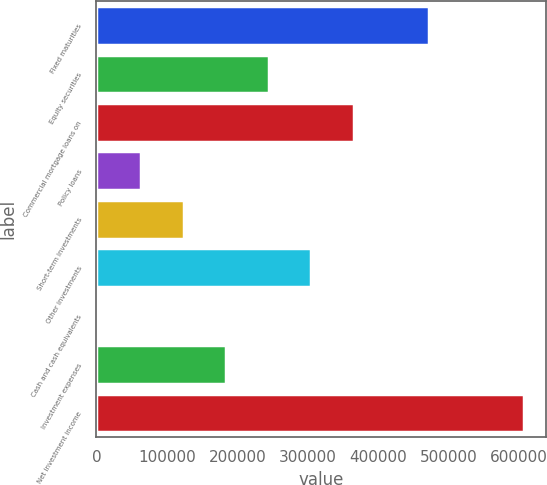Convert chart to OTSL. <chart><loc_0><loc_0><loc_500><loc_500><bar_chart><fcel>Fixed maturities<fcel>Equity securities<fcel>Commercial mortgage loans on<fcel>Policy loans<fcel>Short-term investments<fcel>Other investments<fcel>Cash and cash equivalents<fcel>Investment expenses<fcel>Net investment income<nl><fcel>472717<fcel>244820<fcel>365651<fcel>63573.5<fcel>123989<fcel>305236<fcel>3158<fcel>184404<fcel>607313<nl></chart> 